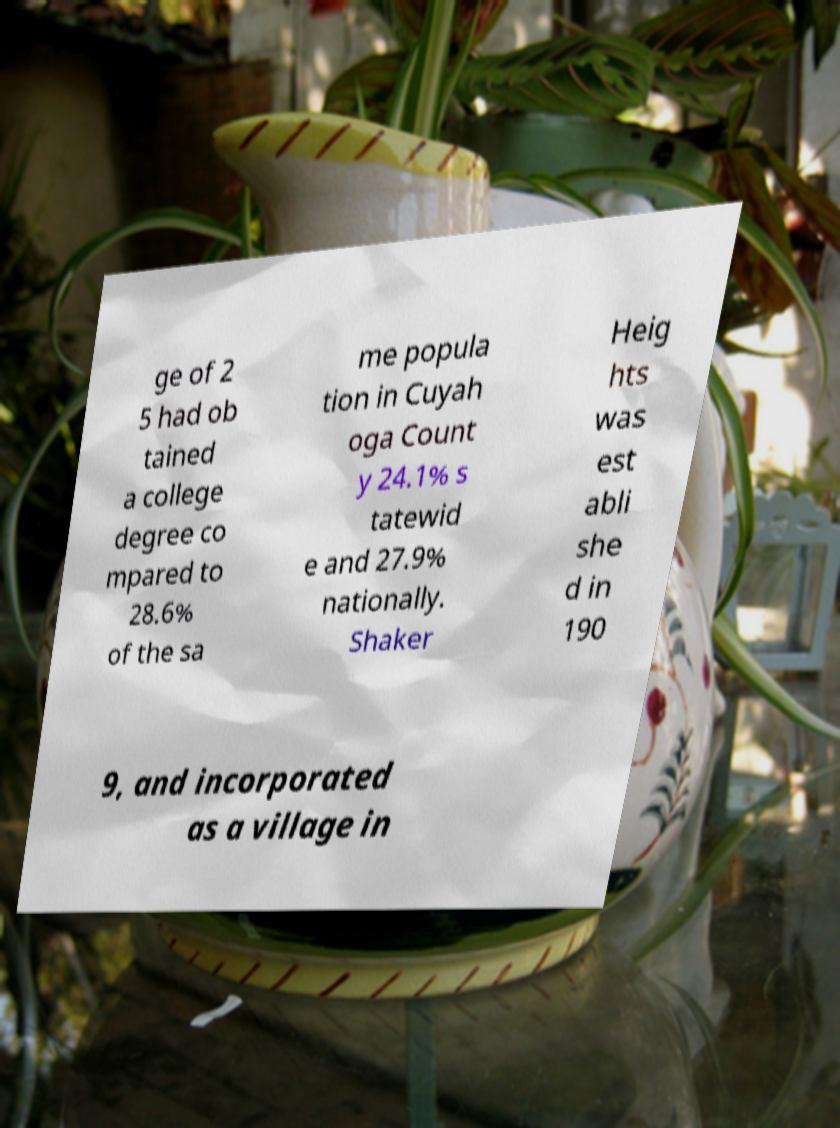Please read and relay the text visible in this image. What does it say? ge of 2 5 had ob tained a college degree co mpared to 28.6% of the sa me popula tion in Cuyah oga Count y 24.1% s tatewid e and 27.9% nationally. Shaker Heig hts was est abli she d in 190 9, and incorporated as a village in 